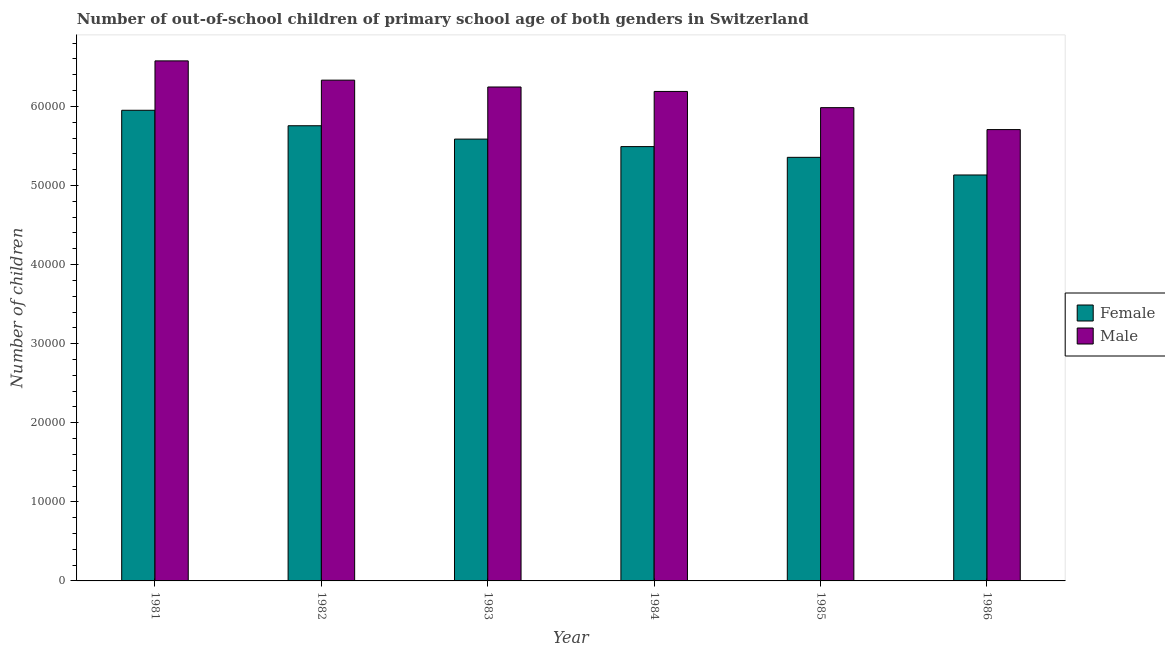How many different coloured bars are there?
Provide a short and direct response. 2. Are the number of bars per tick equal to the number of legend labels?
Your response must be concise. Yes. Are the number of bars on each tick of the X-axis equal?
Ensure brevity in your answer.  Yes. What is the label of the 6th group of bars from the left?
Offer a terse response. 1986. In how many cases, is the number of bars for a given year not equal to the number of legend labels?
Your response must be concise. 0. What is the number of male out-of-school students in 1981?
Provide a succinct answer. 6.58e+04. Across all years, what is the maximum number of female out-of-school students?
Your answer should be very brief. 5.95e+04. Across all years, what is the minimum number of male out-of-school students?
Make the answer very short. 5.71e+04. What is the total number of female out-of-school students in the graph?
Provide a succinct answer. 3.33e+05. What is the difference between the number of female out-of-school students in 1984 and that in 1986?
Give a very brief answer. 3589. What is the difference between the number of female out-of-school students in 1985 and the number of male out-of-school students in 1982?
Give a very brief answer. -3993. What is the average number of male out-of-school students per year?
Your response must be concise. 6.17e+04. What is the ratio of the number of male out-of-school students in 1985 to that in 1986?
Give a very brief answer. 1.05. What is the difference between the highest and the second highest number of male out-of-school students?
Provide a succinct answer. 2437. What is the difference between the highest and the lowest number of male out-of-school students?
Provide a short and direct response. 8688. In how many years, is the number of male out-of-school students greater than the average number of male out-of-school students taken over all years?
Provide a succinct answer. 4. What does the 1st bar from the right in 1985 represents?
Ensure brevity in your answer.  Male. Are all the bars in the graph horizontal?
Make the answer very short. No. How many years are there in the graph?
Keep it short and to the point. 6. What is the difference between two consecutive major ticks on the Y-axis?
Your response must be concise. 10000. Are the values on the major ticks of Y-axis written in scientific E-notation?
Make the answer very short. No. How many legend labels are there?
Provide a succinct answer. 2. How are the legend labels stacked?
Your answer should be very brief. Vertical. What is the title of the graph?
Give a very brief answer. Number of out-of-school children of primary school age of both genders in Switzerland. What is the label or title of the X-axis?
Give a very brief answer. Year. What is the label or title of the Y-axis?
Provide a short and direct response. Number of children. What is the Number of children in Female in 1981?
Your answer should be very brief. 5.95e+04. What is the Number of children in Male in 1981?
Your answer should be very brief. 6.58e+04. What is the Number of children of Female in 1982?
Offer a very short reply. 5.76e+04. What is the Number of children of Male in 1982?
Offer a terse response. 6.33e+04. What is the Number of children of Female in 1983?
Keep it short and to the point. 5.59e+04. What is the Number of children of Male in 1983?
Give a very brief answer. 6.25e+04. What is the Number of children in Female in 1984?
Offer a terse response. 5.49e+04. What is the Number of children of Male in 1984?
Provide a succinct answer. 6.19e+04. What is the Number of children in Female in 1985?
Give a very brief answer. 5.36e+04. What is the Number of children in Male in 1985?
Provide a short and direct response. 5.98e+04. What is the Number of children in Female in 1986?
Offer a terse response. 5.13e+04. What is the Number of children in Male in 1986?
Your answer should be very brief. 5.71e+04. Across all years, what is the maximum Number of children of Female?
Offer a very short reply. 5.95e+04. Across all years, what is the maximum Number of children in Male?
Your answer should be compact. 6.58e+04. Across all years, what is the minimum Number of children in Female?
Keep it short and to the point. 5.13e+04. Across all years, what is the minimum Number of children of Male?
Your answer should be very brief. 5.71e+04. What is the total Number of children of Female in the graph?
Your answer should be compact. 3.33e+05. What is the total Number of children in Male in the graph?
Provide a succinct answer. 3.70e+05. What is the difference between the Number of children of Female in 1981 and that in 1982?
Give a very brief answer. 1957. What is the difference between the Number of children in Male in 1981 and that in 1982?
Ensure brevity in your answer.  2437. What is the difference between the Number of children of Female in 1981 and that in 1983?
Ensure brevity in your answer.  3645. What is the difference between the Number of children of Male in 1981 and that in 1983?
Keep it short and to the point. 3301. What is the difference between the Number of children of Female in 1981 and that in 1984?
Ensure brevity in your answer.  4593. What is the difference between the Number of children in Male in 1981 and that in 1984?
Your response must be concise. 3864. What is the difference between the Number of children in Female in 1981 and that in 1985?
Your answer should be very brief. 5950. What is the difference between the Number of children in Male in 1981 and that in 1985?
Give a very brief answer. 5914. What is the difference between the Number of children in Female in 1981 and that in 1986?
Offer a very short reply. 8182. What is the difference between the Number of children of Male in 1981 and that in 1986?
Keep it short and to the point. 8688. What is the difference between the Number of children of Female in 1982 and that in 1983?
Offer a terse response. 1688. What is the difference between the Number of children in Male in 1982 and that in 1983?
Keep it short and to the point. 864. What is the difference between the Number of children in Female in 1982 and that in 1984?
Provide a short and direct response. 2636. What is the difference between the Number of children of Male in 1982 and that in 1984?
Your answer should be compact. 1427. What is the difference between the Number of children of Female in 1982 and that in 1985?
Your response must be concise. 3993. What is the difference between the Number of children in Male in 1982 and that in 1985?
Provide a succinct answer. 3477. What is the difference between the Number of children of Female in 1982 and that in 1986?
Your response must be concise. 6225. What is the difference between the Number of children in Male in 1982 and that in 1986?
Your answer should be compact. 6251. What is the difference between the Number of children in Female in 1983 and that in 1984?
Your response must be concise. 948. What is the difference between the Number of children in Male in 1983 and that in 1984?
Your response must be concise. 563. What is the difference between the Number of children of Female in 1983 and that in 1985?
Offer a very short reply. 2305. What is the difference between the Number of children of Male in 1983 and that in 1985?
Your response must be concise. 2613. What is the difference between the Number of children in Female in 1983 and that in 1986?
Offer a terse response. 4537. What is the difference between the Number of children in Male in 1983 and that in 1986?
Keep it short and to the point. 5387. What is the difference between the Number of children of Female in 1984 and that in 1985?
Provide a succinct answer. 1357. What is the difference between the Number of children in Male in 1984 and that in 1985?
Your answer should be compact. 2050. What is the difference between the Number of children in Female in 1984 and that in 1986?
Your answer should be very brief. 3589. What is the difference between the Number of children of Male in 1984 and that in 1986?
Keep it short and to the point. 4824. What is the difference between the Number of children of Female in 1985 and that in 1986?
Your response must be concise. 2232. What is the difference between the Number of children of Male in 1985 and that in 1986?
Make the answer very short. 2774. What is the difference between the Number of children of Female in 1981 and the Number of children of Male in 1982?
Provide a succinct answer. -3808. What is the difference between the Number of children of Female in 1981 and the Number of children of Male in 1983?
Give a very brief answer. -2944. What is the difference between the Number of children of Female in 1981 and the Number of children of Male in 1984?
Give a very brief answer. -2381. What is the difference between the Number of children of Female in 1981 and the Number of children of Male in 1985?
Your response must be concise. -331. What is the difference between the Number of children of Female in 1981 and the Number of children of Male in 1986?
Make the answer very short. 2443. What is the difference between the Number of children in Female in 1982 and the Number of children in Male in 1983?
Offer a very short reply. -4901. What is the difference between the Number of children in Female in 1982 and the Number of children in Male in 1984?
Your answer should be very brief. -4338. What is the difference between the Number of children in Female in 1982 and the Number of children in Male in 1985?
Make the answer very short. -2288. What is the difference between the Number of children in Female in 1982 and the Number of children in Male in 1986?
Provide a succinct answer. 486. What is the difference between the Number of children of Female in 1983 and the Number of children of Male in 1984?
Provide a succinct answer. -6026. What is the difference between the Number of children of Female in 1983 and the Number of children of Male in 1985?
Ensure brevity in your answer.  -3976. What is the difference between the Number of children of Female in 1983 and the Number of children of Male in 1986?
Ensure brevity in your answer.  -1202. What is the difference between the Number of children in Female in 1984 and the Number of children in Male in 1985?
Make the answer very short. -4924. What is the difference between the Number of children in Female in 1984 and the Number of children in Male in 1986?
Provide a short and direct response. -2150. What is the difference between the Number of children of Female in 1985 and the Number of children of Male in 1986?
Your answer should be very brief. -3507. What is the average Number of children in Female per year?
Provide a succinct answer. 5.55e+04. What is the average Number of children in Male per year?
Your answer should be compact. 6.17e+04. In the year 1981, what is the difference between the Number of children of Female and Number of children of Male?
Make the answer very short. -6245. In the year 1982, what is the difference between the Number of children of Female and Number of children of Male?
Offer a very short reply. -5765. In the year 1983, what is the difference between the Number of children in Female and Number of children in Male?
Your answer should be compact. -6589. In the year 1984, what is the difference between the Number of children in Female and Number of children in Male?
Provide a succinct answer. -6974. In the year 1985, what is the difference between the Number of children of Female and Number of children of Male?
Provide a succinct answer. -6281. In the year 1986, what is the difference between the Number of children in Female and Number of children in Male?
Provide a succinct answer. -5739. What is the ratio of the Number of children of Female in 1981 to that in 1982?
Provide a short and direct response. 1.03. What is the ratio of the Number of children in Male in 1981 to that in 1982?
Your answer should be compact. 1.04. What is the ratio of the Number of children in Female in 1981 to that in 1983?
Provide a succinct answer. 1.07. What is the ratio of the Number of children in Male in 1981 to that in 1983?
Give a very brief answer. 1.05. What is the ratio of the Number of children in Female in 1981 to that in 1984?
Ensure brevity in your answer.  1.08. What is the ratio of the Number of children of Male in 1981 to that in 1984?
Your answer should be very brief. 1.06. What is the ratio of the Number of children of Female in 1981 to that in 1985?
Your answer should be very brief. 1.11. What is the ratio of the Number of children of Male in 1981 to that in 1985?
Your answer should be compact. 1.1. What is the ratio of the Number of children in Female in 1981 to that in 1986?
Your answer should be very brief. 1.16. What is the ratio of the Number of children in Male in 1981 to that in 1986?
Offer a terse response. 1.15. What is the ratio of the Number of children in Female in 1982 to that in 1983?
Your response must be concise. 1.03. What is the ratio of the Number of children in Male in 1982 to that in 1983?
Offer a very short reply. 1.01. What is the ratio of the Number of children of Female in 1982 to that in 1984?
Ensure brevity in your answer.  1.05. What is the ratio of the Number of children of Male in 1982 to that in 1984?
Your answer should be very brief. 1.02. What is the ratio of the Number of children of Female in 1982 to that in 1985?
Your answer should be very brief. 1.07. What is the ratio of the Number of children in Male in 1982 to that in 1985?
Your answer should be very brief. 1.06. What is the ratio of the Number of children in Female in 1982 to that in 1986?
Provide a short and direct response. 1.12. What is the ratio of the Number of children of Male in 1982 to that in 1986?
Give a very brief answer. 1.11. What is the ratio of the Number of children of Female in 1983 to that in 1984?
Ensure brevity in your answer.  1.02. What is the ratio of the Number of children in Male in 1983 to that in 1984?
Your answer should be very brief. 1.01. What is the ratio of the Number of children of Female in 1983 to that in 1985?
Make the answer very short. 1.04. What is the ratio of the Number of children in Male in 1983 to that in 1985?
Keep it short and to the point. 1.04. What is the ratio of the Number of children of Female in 1983 to that in 1986?
Provide a succinct answer. 1.09. What is the ratio of the Number of children in Male in 1983 to that in 1986?
Make the answer very short. 1.09. What is the ratio of the Number of children in Female in 1984 to that in 1985?
Your answer should be compact. 1.03. What is the ratio of the Number of children in Male in 1984 to that in 1985?
Make the answer very short. 1.03. What is the ratio of the Number of children of Female in 1984 to that in 1986?
Provide a succinct answer. 1.07. What is the ratio of the Number of children in Male in 1984 to that in 1986?
Offer a very short reply. 1.08. What is the ratio of the Number of children of Female in 1985 to that in 1986?
Offer a terse response. 1.04. What is the ratio of the Number of children of Male in 1985 to that in 1986?
Your answer should be compact. 1.05. What is the difference between the highest and the second highest Number of children in Female?
Provide a succinct answer. 1957. What is the difference between the highest and the second highest Number of children of Male?
Offer a very short reply. 2437. What is the difference between the highest and the lowest Number of children in Female?
Your response must be concise. 8182. What is the difference between the highest and the lowest Number of children in Male?
Provide a succinct answer. 8688. 